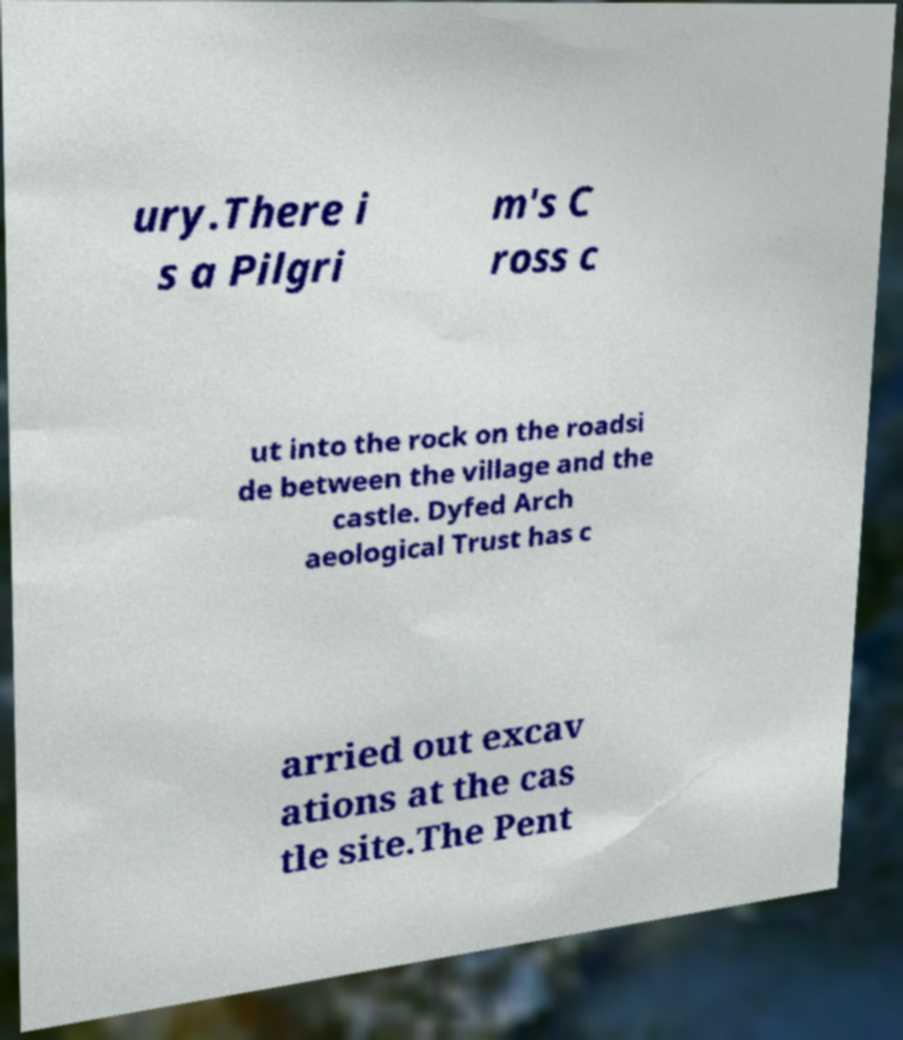I need the written content from this picture converted into text. Can you do that? ury.There i s a Pilgri m's C ross c ut into the rock on the roadsi de between the village and the castle. Dyfed Arch aeological Trust has c arried out excav ations at the cas tle site.The Pent 